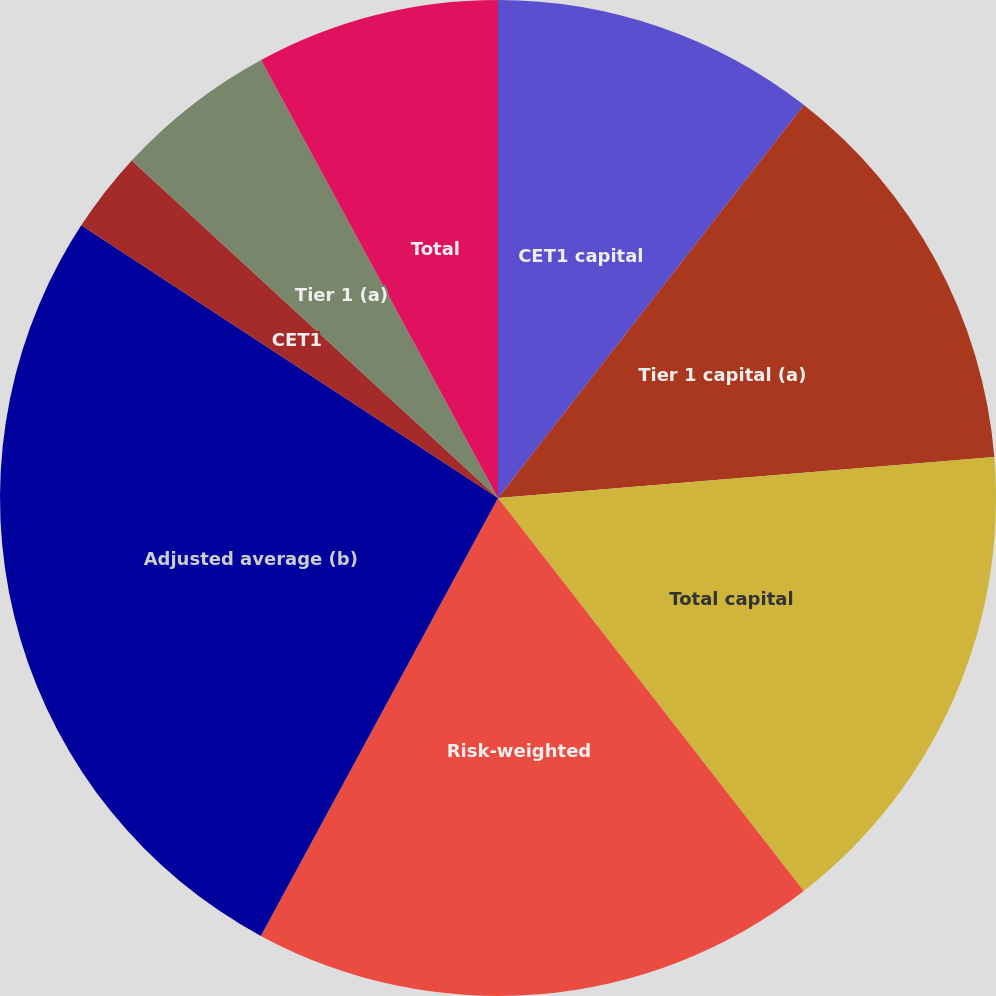Convert chart. <chart><loc_0><loc_0><loc_500><loc_500><pie_chart><fcel>CET1 capital<fcel>Tier 1 capital (a)<fcel>Total capital<fcel>Risk-weighted<fcel>Adjusted average (b)<fcel>CET1<fcel>Tier 1 (a)<fcel>Total<fcel>Tier 1 leverage (d)<nl><fcel>10.53%<fcel>13.16%<fcel>15.79%<fcel>18.42%<fcel>26.32%<fcel>2.63%<fcel>5.26%<fcel>7.89%<fcel>0.0%<nl></chart> 